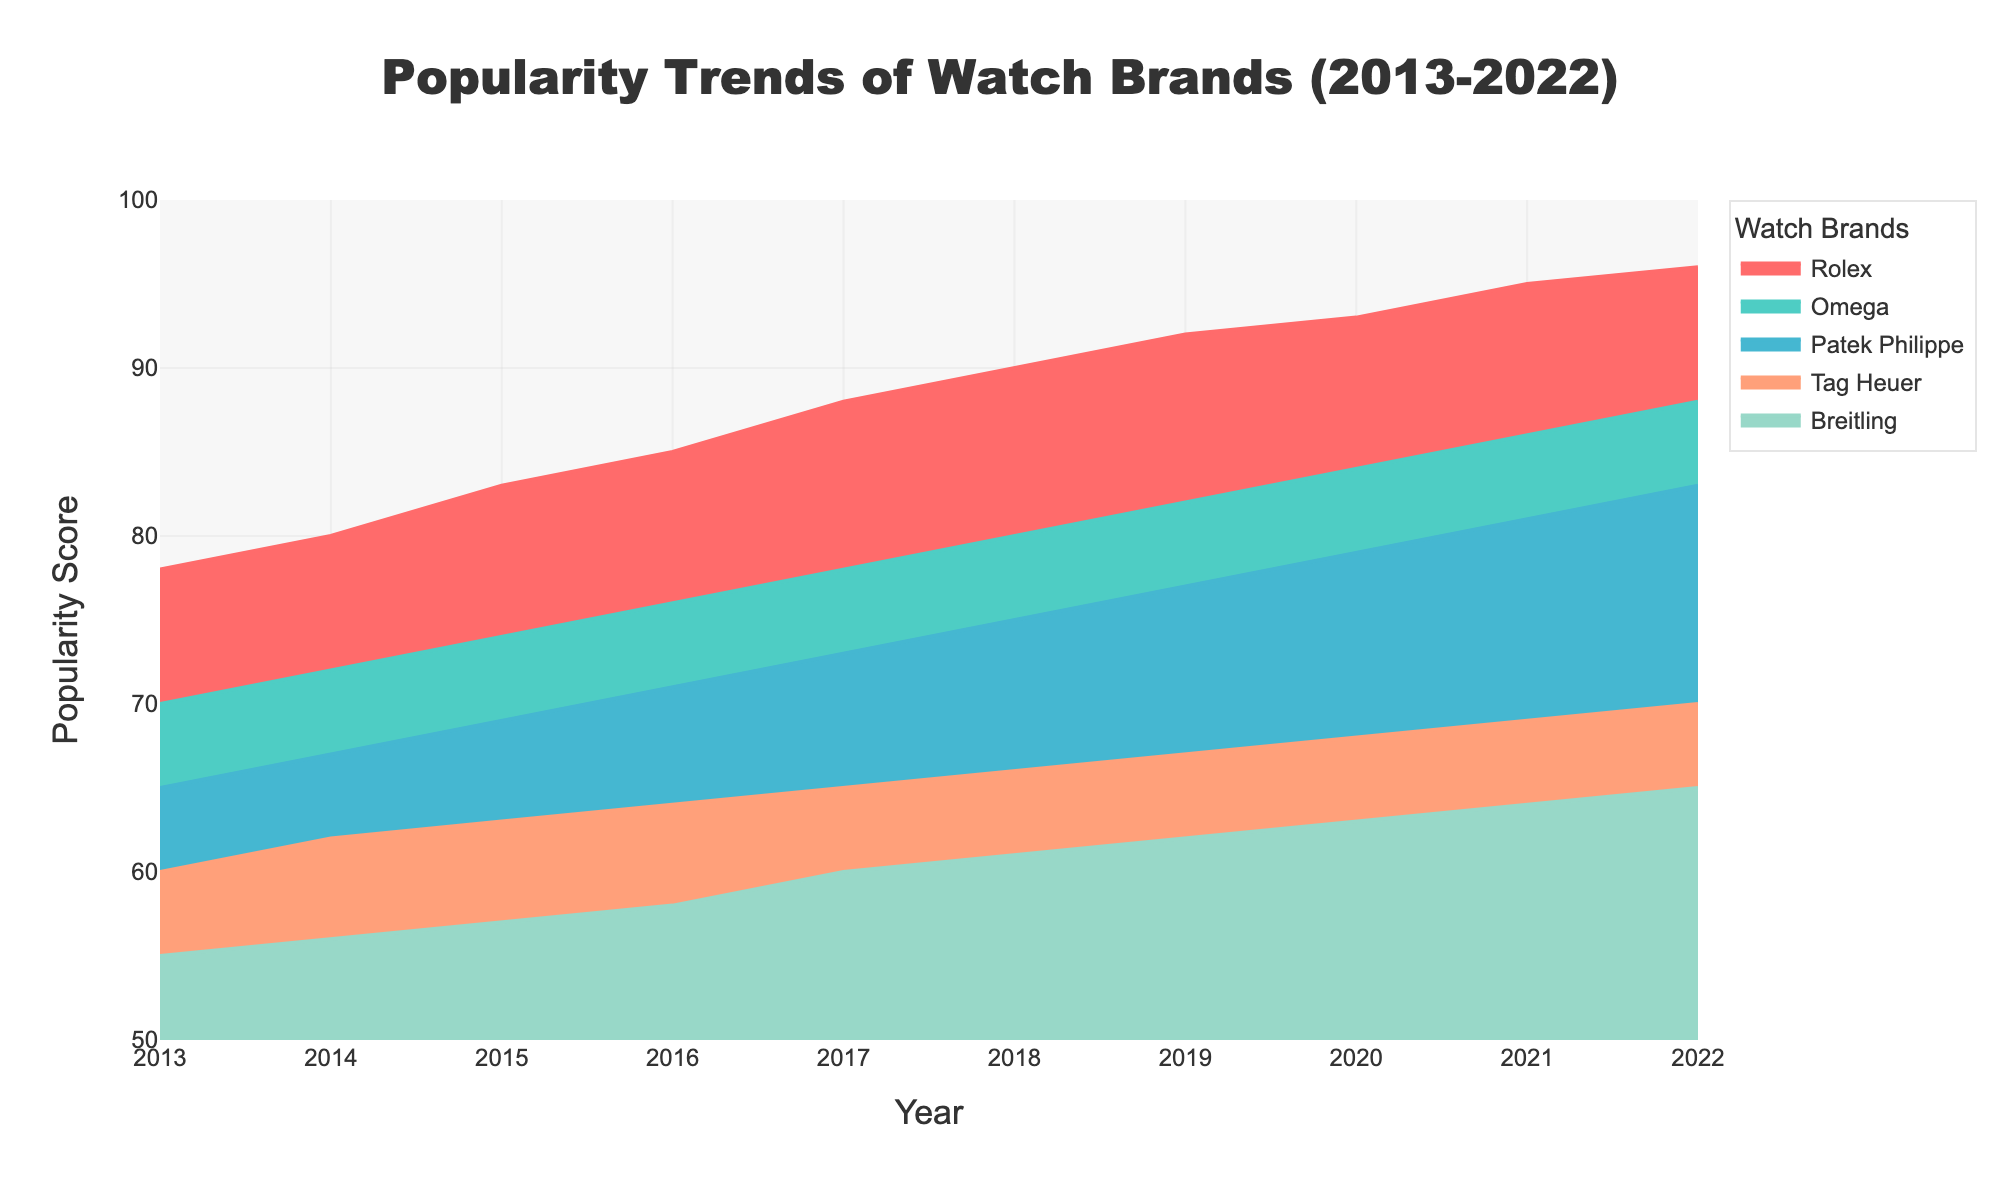What's the highest popularity score reached by Rolex within the decade? Observe the area chart and look for the peak value of the 'Rolex' line. The highest popularity score for Rolex is found in the year 2022, reaching 96.
Answer: 96 In which year did Omega's popularity score first reach 80? Examine the area under the 'Omega' line. Omega's popularity score first reaches 80 in the year 2018.
Answer: 2018 What is the difference between Patek Philippe's and Tag Heuer's popularity scores in 2018? Find both Patek Philippe's and Tag Heuer's popularity scores for the year 2018. Patek Philippe has a score of 75, while Tag Heuer has a score of 66. The difference is 75 - 66.
Answer: 9 Which brand showed the least increase in popularity score from 2013 to 2022? Compare the initial and final popularity scores for all brands: Rolex (78 to 96 = 18), Omega (70 to 88 = 18), Patek Philippe (65 to 83 = 18), Tag Heuer (60 to 70 = 10), Breitling (55 to 65 = 10). Both Tag Heuer and Breitling show the least increase, which is 10.
Answer: Tag Heuer and Breitling When did Breitling's popularity score reach 60? Locate the year when Breitling's score first meets or exceeds 60. According to the chart, Breitling's score reached 60 in the year 2017.
Answer: 2017 Which watch brand had the steepest increase in popularity score between any two consecutive years? Look for the sharpest rise between any two points for each brand. The steepest increase appears in Rolex from 2016 (85) to 2017 (88), which is an increase of 3 points.
Answer: Rolex between 2016 and 2017 How does the popularity trend of Omega compare with Patek Philippe over the decade? Observe both the Omega and Patek Philippe lines over the years 2013 to 2022. Both brands show a consistent increase, but Omega's trend is consistently higher than Patek Philippe.
Answer: Omega consistently higher 